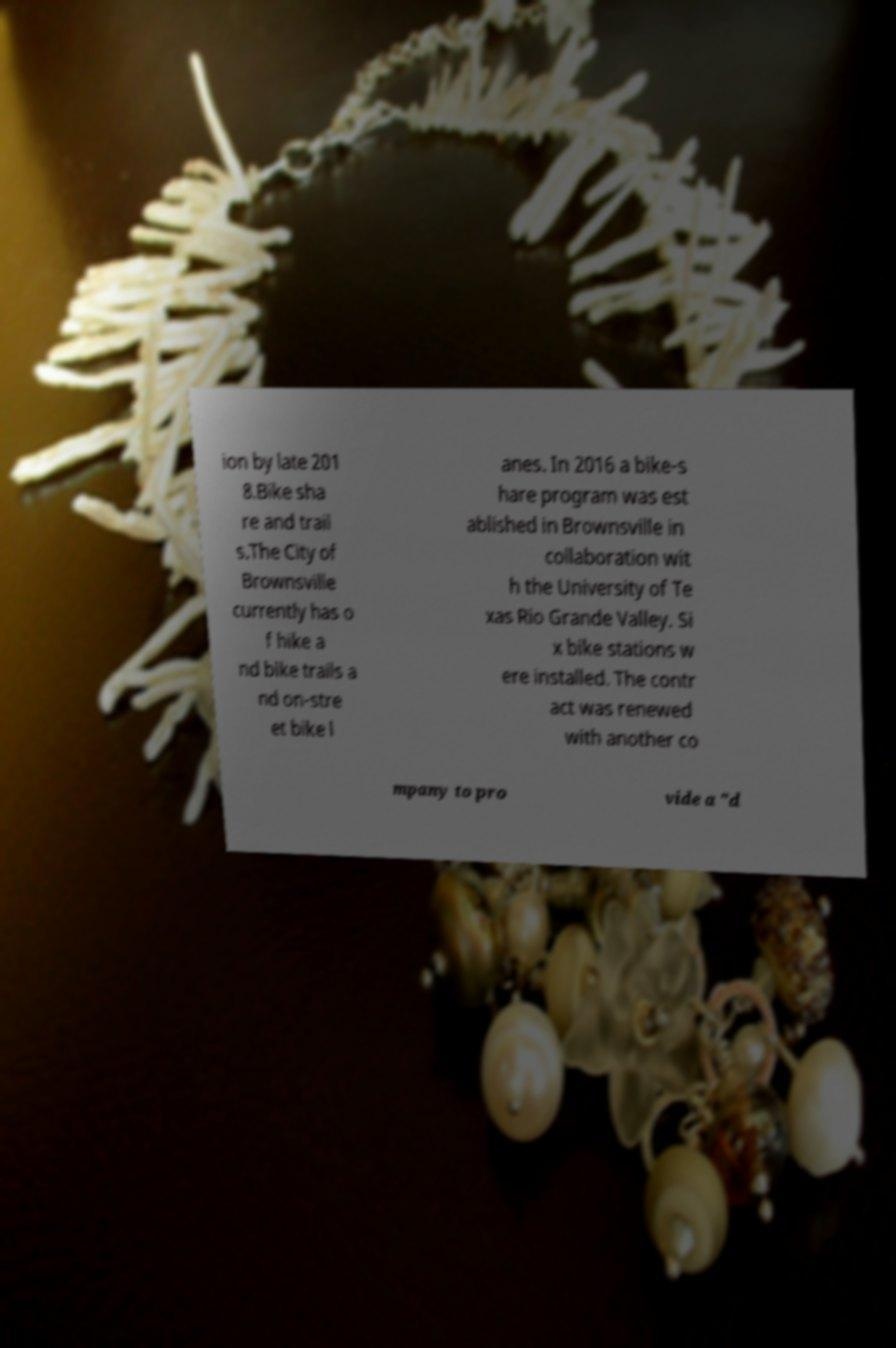For documentation purposes, I need the text within this image transcribed. Could you provide that? ion by late 201 8.Bike sha re and trail s.The City of Brownsville currently has o f hike a nd bike trails a nd on-stre et bike l anes. In 2016 a bike-s hare program was est ablished in Brownsville in collaboration wit h the University of Te xas Rio Grande Valley. Si x bike stations w ere installed. The contr act was renewed with another co mpany to pro vide a "d 